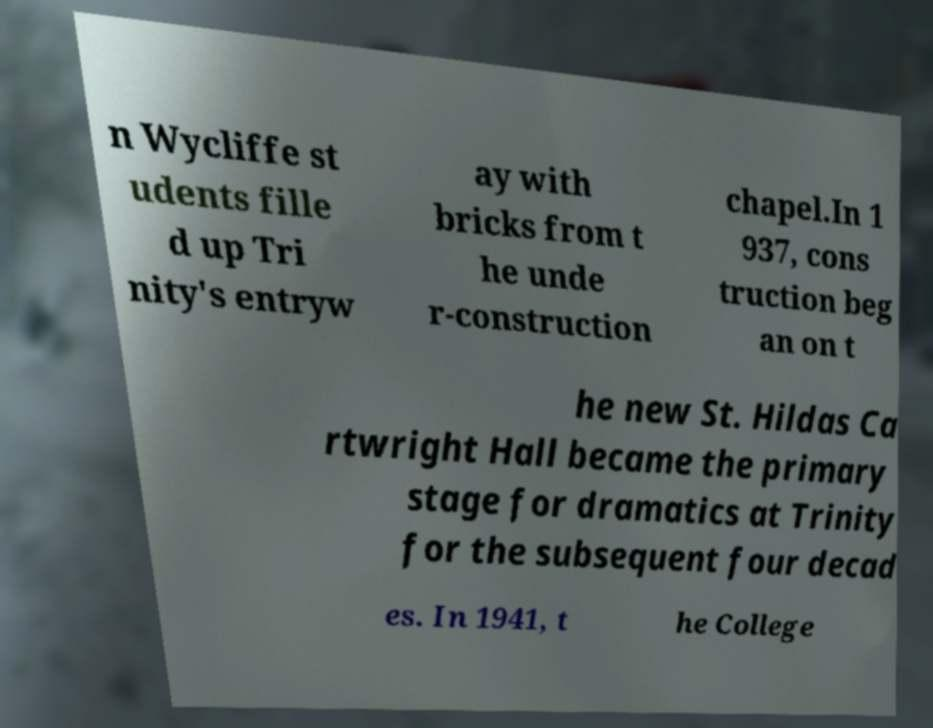Can you read and provide the text displayed in the image?This photo seems to have some interesting text. Can you extract and type it out for me? n Wycliffe st udents fille d up Tri nity's entryw ay with bricks from t he unde r-construction chapel.In 1 937, cons truction beg an on t he new St. Hildas Ca rtwright Hall became the primary stage for dramatics at Trinity for the subsequent four decad es. In 1941, t he College 